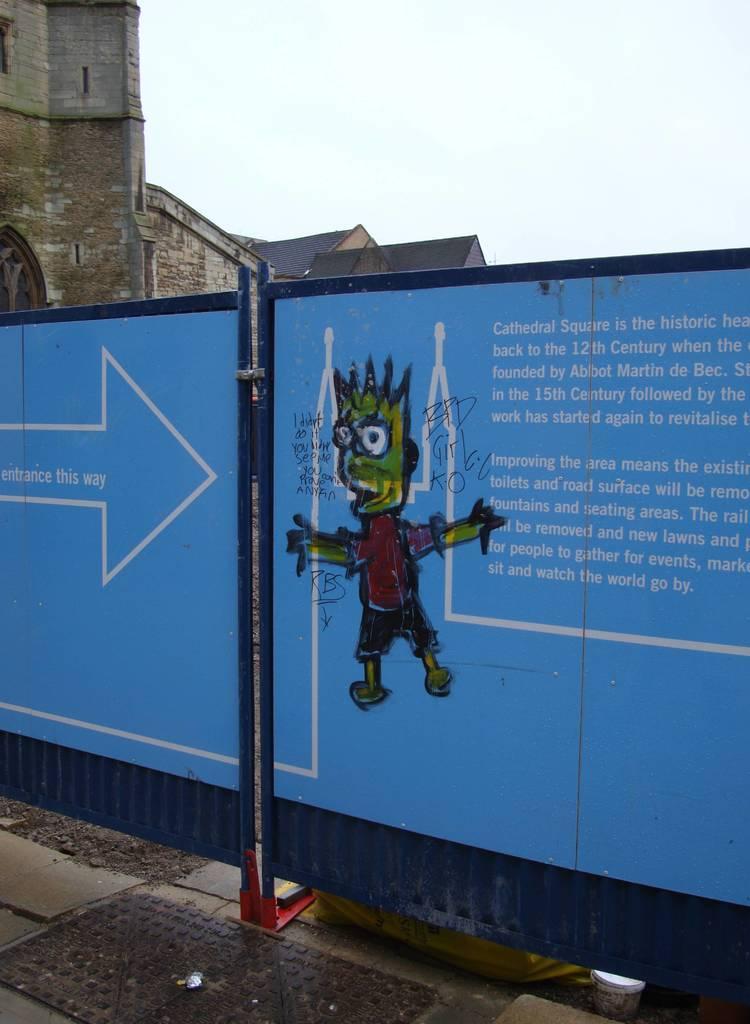Describe this image in one or two sentences. In this image, we can see a board. There is a building in the top left of the image. There is a sky at the top of the image. 